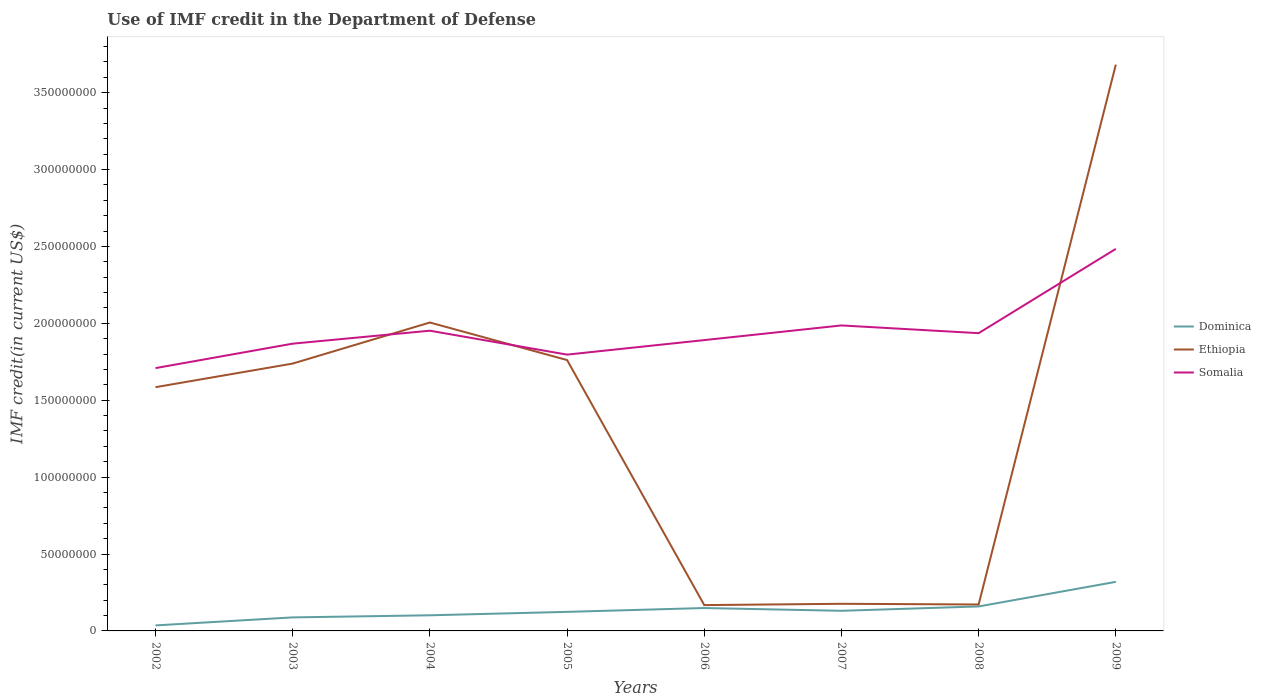Does the line corresponding to Somalia intersect with the line corresponding to Dominica?
Give a very brief answer. No. Across all years, what is the maximum IMF credit in the Department of Defense in Somalia?
Your answer should be very brief. 1.71e+08. In which year was the IMF credit in the Department of Defense in Dominica maximum?
Give a very brief answer. 2002. What is the total IMF credit in the Department of Defense in Somalia in the graph?
Ensure brevity in your answer.  -2.27e+07. What is the difference between the highest and the second highest IMF credit in the Department of Defense in Ethiopia?
Keep it short and to the point. 3.51e+08. Is the IMF credit in the Department of Defense in Ethiopia strictly greater than the IMF credit in the Department of Defense in Somalia over the years?
Offer a very short reply. No. How many legend labels are there?
Offer a terse response. 3. What is the title of the graph?
Offer a terse response. Use of IMF credit in the Department of Defense. What is the label or title of the X-axis?
Your response must be concise. Years. What is the label or title of the Y-axis?
Make the answer very short. IMF credit(in current US$). What is the IMF credit(in current US$) in Dominica in 2002?
Give a very brief answer. 3.59e+06. What is the IMF credit(in current US$) of Ethiopia in 2002?
Your answer should be very brief. 1.58e+08. What is the IMF credit(in current US$) of Somalia in 2002?
Provide a short and direct response. 1.71e+08. What is the IMF credit(in current US$) of Dominica in 2003?
Provide a short and direct response. 8.80e+06. What is the IMF credit(in current US$) in Ethiopia in 2003?
Your answer should be compact. 1.74e+08. What is the IMF credit(in current US$) of Somalia in 2003?
Provide a succinct answer. 1.87e+08. What is the IMF credit(in current US$) in Dominica in 2004?
Your answer should be very brief. 1.02e+07. What is the IMF credit(in current US$) of Ethiopia in 2004?
Offer a very short reply. 2.01e+08. What is the IMF credit(in current US$) in Somalia in 2004?
Offer a very short reply. 1.95e+08. What is the IMF credit(in current US$) of Dominica in 2005?
Ensure brevity in your answer.  1.24e+07. What is the IMF credit(in current US$) in Ethiopia in 2005?
Keep it short and to the point. 1.76e+08. What is the IMF credit(in current US$) of Somalia in 2005?
Keep it short and to the point. 1.80e+08. What is the IMF credit(in current US$) in Dominica in 2006?
Provide a succinct answer. 1.49e+07. What is the IMF credit(in current US$) of Ethiopia in 2006?
Provide a succinct answer. 1.68e+07. What is the IMF credit(in current US$) in Somalia in 2006?
Provide a succinct answer. 1.89e+08. What is the IMF credit(in current US$) of Dominica in 2007?
Your answer should be very brief. 1.31e+07. What is the IMF credit(in current US$) of Ethiopia in 2007?
Your response must be concise. 1.76e+07. What is the IMF credit(in current US$) in Somalia in 2007?
Offer a terse response. 1.99e+08. What is the IMF credit(in current US$) of Dominica in 2008?
Offer a terse response. 1.59e+07. What is the IMF credit(in current US$) of Ethiopia in 2008?
Provide a succinct answer. 1.72e+07. What is the IMF credit(in current US$) of Somalia in 2008?
Give a very brief answer. 1.94e+08. What is the IMF credit(in current US$) of Dominica in 2009?
Make the answer very short. 3.19e+07. What is the IMF credit(in current US$) of Ethiopia in 2009?
Offer a terse response. 3.68e+08. What is the IMF credit(in current US$) of Somalia in 2009?
Your answer should be very brief. 2.48e+08. Across all years, what is the maximum IMF credit(in current US$) in Dominica?
Offer a very short reply. 3.19e+07. Across all years, what is the maximum IMF credit(in current US$) in Ethiopia?
Make the answer very short. 3.68e+08. Across all years, what is the maximum IMF credit(in current US$) of Somalia?
Offer a terse response. 2.48e+08. Across all years, what is the minimum IMF credit(in current US$) in Dominica?
Give a very brief answer. 3.59e+06. Across all years, what is the minimum IMF credit(in current US$) of Ethiopia?
Give a very brief answer. 1.68e+07. Across all years, what is the minimum IMF credit(in current US$) in Somalia?
Offer a terse response. 1.71e+08. What is the total IMF credit(in current US$) of Dominica in the graph?
Your answer should be very brief. 1.11e+08. What is the total IMF credit(in current US$) of Ethiopia in the graph?
Provide a short and direct response. 1.13e+09. What is the total IMF credit(in current US$) in Somalia in the graph?
Give a very brief answer. 1.56e+09. What is the difference between the IMF credit(in current US$) in Dominica in 2002 and that in 2003?
Offer a very short reply. -5.21e+06. What is the difference between the IMF credit(in current US$) in Ethiopia in 2002 and that in 2003?
Your answer should be compact. -1.54e+07. What is the difference between the IMF credit(in current US$) of Somalia in 2002 and that in 2003?
Ensure brevity in your answer.  -1.59e+07. What is the difference between the IMF credit(in current US$) of Dominica in 2002 and that in 2004?
Your answer should be compact. -6.56e+06. What is the difference between the IMF credit(in current US$) of Ethiopia in 2002 and that in 2004?
Provide a succinct answer. -4.21e+07. What is the difference between the IMF credit(in current US$) of Somalia in 2002 and that in 2004?
Provide a short and direct response. -2.43e+07. What is the difference between the IMF credit(in current US$) in Dominica in 2002 and that in 2005?
Your response must be concise. -8.81e+06. What is the difference between the IMF credit(in current US$) in Ethiopia in 2002 and that in 2005?
Keep it short and to the point. -1.76e+07. What is the difference between the IMF credit(in current US$) in Somalia in 2002 and that in 2005?
Your response must be concise. -8.77e+06. What is the difference between the IMF credit(in current US$) of Dominica in 2002 and that in 2006?
Offer a very short reply. -1.13e+07. What is the difference between the IMF credit(in current US$) in Ethiopia in 2002 and that in 2006?
Provide a short and direct response. 1.42e+08. What is the difference between the IMF credit(in current US$) in Somalia in 2002 and that in 2006?
Make the answer very short. -1.82e+07. What is the difference between the IMF credit(in current US$) in Dominica in 2002 and that in 2007?
Make the answer very short. -9.49e+06. What is the difference between the IMF credit(in current US$) in Ethiopia in 2002 and that in 2007?
Offer a very short reply. 1.41e+08. What is the difference between the IMF credit(in current US$) in Somalia in 2002 and that in 2007?
Make the answer very short. -2.77e+07. What is the difference between the IMF credit(in current US$) of Dominica in 2002 and that in 2008?
Your answer should be very brief. -1.23e+07. What is the difference between the IMF credit(in current US$) in Ethiopia in 2002 and that in 2008?
Keep it short and to the point. 1.41e+08. What is the difference between the IMF credit(in current US$) in Somalia in 2002 and that in 2008?
Offer a terse response. -2.27e+07. What is the difference between the IMF credit(in current US$) in Dominica in 2002 and that in 2009?
Provide a short and direct response. -2.83e+07. What is the difference between the IMF credit(in current US$) in Ethiopia in 2002 and that in 2009?
Your answer should be compact. -2.10e+08. What is the difference between the IMF credit(in current US$) of Somalia in 2002 and that in 2009?
Provide a succinct answer. -7.75e+07. What is the difference between the IMF credit(in current US$) of Dominica in 2003 and that in 2004?
Give a very brief answer. -1.35e+06. What is the difference between the IMF credit(in current US$) in Ethiopia in 2003 and that in 2004?
Give a very brief answer. -2.67e+07. What is the difference between the IMF credit(in current US$) of Somalia in 2003 and that in 2004?
Make the answer very short. -8.43e+06. What is the difference between the IMF credit(in current US$) of Dominica in 2003 and that in 2005?
Make the answer very short. -3.60e+06. What is the difference between the IMF credit(in current US$) of Ethiopia in 2003 and that in 2005?
Offer a terse response. -2.28e+06. What is the difference between the IMF credit(in current US$) of Somalia in 2003 and that in 2005?
Provide a succinct answer. 7.13e+06. What is the difference between the IMF credit(in current US$) of Dominica in 2003 and that in 2006?
Keep it short and to the point. -6.08e+06. What is the difference between the IMF credit(in current US$) in Ethiopia in 2003 and that in 2006?
Provide a short and direct response. 1.57e+08. What is the difference between the IMF credit(in current US$) in Somalia in 2003 and that in 2006?
Provide a succinct answer. -2.32e+06. What is the difference between the IMF credit(in current US$) of Dominica in 2003 and that in 2007?
Your answer should be very brief. -4.28e+06. What is the difference between the IMF credit(in current US$) in Ethiopia in 2003 and that in 2007?
Your answer should be very brief. 1.56e+08. What is the difference between the IMF credit(in current US$) in Somalia in 2003 and that in 2007?
Your response must be concise. -1.19e+07. What is the difference between the IMF credit(in current US$) in Dominica in 2003 and that in 2008?
Provide a succinct answer. -7.11e+06. What is the difference between the IMF credit(in current US$) of Ethiopia in 2003 and that in 2008?
Provide a succinct answer. 1.57e+08. What is the difference between the IMF credit(in current US$) of Somalia in 2003 and that in 2008?
Offer a very short reply. -6.83e+06. What is the difference between the IMF credit(in current US$) of Dominica in 2003 and that in 2009?
Ensure brevity in your answer.  -2.31e+07. What is the difference between the IMF credit(in current US$) in Ethiopia in 2003 and that in 2009?
Your response must be concise. -1.94e+08. What is the difference between the IMF credit(in current US$) of Somalia in 2003 and that in 2009?
Provide a short and direct response. -6.16e+07. What is the difference between the IMF credit(in current US$) in Dominica in 2004 and that in 2005?
Keep it short and to the point. -2.24e+06. What is the difference between the IMF credit(in current US$) of Ethiopia in 2004 and that in 2005?
Ensure brevity in your answer.  2.44e+07. What is the difference between the IMF credit(in current US$) in Somalia in 2004 and that in 2005?
Your answer should be compact. 1.56e+07. What is the difference between the IMF credit(in current US$) of Dominica in 2004 and that in 2006?
Your answer should be very brief. -4.73e+06. What is the difference between the IMF credit(in current US$) in Ethiopia in 2004 and that in 2006?
Keep it short and to the point. 1.84e+08. What is the difference between the IMF credit(in current US$) in Somalia in 2004 and that in 2006?
Your answer should be compact. 6.11e+06. What is the difference between the IMF credit(in current US$) in Dominica in 2004 and that in 2007?
Ensure brevity in your answer.  -2.93e+06. What is the difference between the IMF credit(in current US$) of Ethiopia in 2004 and that in 2007?
Provide a short and direct response. 1.83e+08. What is the difference between the IMF credit(in current US$) in Somalia in 2004 and that in 2007?
Provide a short and direct response. -3.42e+06. What is the difference between the IMF credit(in current US$) in Dominica in 2004 and that in 2008?
Give a very brief answer. -5.76e+06. What is the difference between the IMF credit(in current US$) in Ethiopia in 2004 and that in 2008?
Give a very brief answer. 1.83e+08. What is the difference between the IMF credit(in current US$) of Somalia in 2004 and that in 2008?
Offer a terse response. 1.60e+06. What is the difference between the IMF credit(in current US$) of Dominica in 2004 and that in 2009?
Offer a terse response. -2.18e+07. What is the difference between the IMF credit(in current US$) in Ethiopia in 2004 and that in 2009?
Your answer should be very brief. -1.68e+08. What is the difference between the IMF credit(in current US$) in Somalia in 2004 and that in 2009?
Your answer should be very brief. -5.32e+07. What is the difference between the IMF credit(in current US$) in Dominica in 2005 and that in 2006?
Your answer should be compact. -2.49e+06. What is the difference between the IMF credit(in current US$) in Ethiopia in 2005 and that in 2006?
Your answer should be compact. 1.59e+08. What is the difference between the IMF credit(in current US$) in Somalia in 2005 and that in 2006?
Make the answer very short. -9.44e+06. What is the difference between the IMF credit(in current US$) in Dominica in 2005 and that in 2007?
Your answer should be very brief. -6.87e+05. What is the difference between the IMF credit(in current US$) in Ethiopia in 2005 and that in 2007?
Your answer should be compact. 1.58e+08. What is the difference between the IMF credit(in current US$) in Somalia in 2005 and that in 2007?
Provide a succinct answer. -1.90e+07. What is the difference between the IMF credit(in current US$) of Dominica in 2005 and that in 2008?
Provide a short and direct response. -3.51e+06. What is the difference between the IMF credit(in current US$) of Ethiopia in 2005 and that in 2008?
Offer a very short reply. 1.59e+08. What is the difference between the IMF credit(in current US$) in Somalia in 2005 and that in 2008?
Ensure brevity in your answer.  -1.40e+07. What is the difference between the IMF credit(in current US$) of Dominica in 2005 and that in 2009?
Keep it short and to the point. -1.95e+07. What is the difference between the IMF credit(in current US$) of Ethiopia in 2005 and that in 2009?
Your answer should be compact. -1.92e+08. What is the difference between the IMF credit(in current US$) of Somalia in 2005 and that in 2009?
Give a very brief answer. -6.88e+07. What is the difference between the IMF credit(in current US$) in Dominica in 2006 and that in 2007?
Provide a succinct answer. 1.80e+06. What is the difference between the IMF credit(in current US$) of Ethiopia in 2006 and that in 2007?
Offer a very short reply. -8.47e+05. What is the difference between the IMF credit(in current US$) of Somalia in 2006 and that in 2007?
Your answer should be very brief. -9.53e+06. What is the difference between the IMF credit(in current US$) of Dominica in 2006 and that in 2008?
Offer a very short reply. -1.03e+06. What is the difference between the IMF credit(in current US$) of Ethiopia in 2006 and that in 2008?
Your answer should be very brief. -4.00e+05. What is the difference between the IMF credit(in current US$) of Somalia in 2006 and that in 2008?
Give a very brief answer. -4.51e+06. What is the difference between the IMF credit(in current US$) of Dominica in 2006 and that in 2009?
Your answer should be compact. -1.70e+07. What is the difference between the IMF credit(in current US$) of Ethiopia in 2006 and that in 2009?
Provide a succinct answer. -3.51e+08. What is the difference between the IMF credit(in current US$) in Somalia in 2006 and that in 2009?
Offer a terse response. -5.93e+07. What is the difference between the IMF credit(in current US$) in Dominica in 2007 and that in 2008?
Your answer should be very brief. -2.83e+06. What is the difference between the IMF credit(in current US$) of Ethiopia in 2007 and that in 2008?
Ensure brevity in your answer.  4.47e+05. What is the difference between the IMF credit(in current US$) in Somalia in 2007 and that in 2008?
Your answer should be compact. 5.02e+06. What is the difference between the IMF credit(in current US$) in Dominica in 2007 and that in 2009?
Ensure brevity in your answer.  -1.88e+07. What is the difference between the IMF credit(in current US$) of Ethiopia in 2007 and that in 2009?
Your answer should be very brief. -3.51e+08. What is the difference between the IMF credit(in current US$) in Somalia in 2007 and that in 2009?
Make the answer very short. -4.98e+07. What is the difference between the IMF credit(in current US$) in Dominica in 2008 and that in 2009?
Offer a very short reply. -1.60e+07. What is the difference between the IMF credit(in current US$) of Ethiopia in 2008 and that in 2009?
Make the answer very short. -3.51e+08. What is the difference between the IMF credit(in current US$) in Somalia in 2008 and that in 2009?
Offer a terse response. -5.48e+07. What is the difference between the IMF credit(in current US$) of Dominica in 2002 and the IMF credit(in current US$) of Ethiopia in 2003?
Give a very brief answer. -1.70e+08. What is the difference between the IMF credit(in current US$) of Dominica in 2002 and the IMF credit(in current US$) of Somalia in 2003?
Your answer should be very brief. -1.83e+08. What is the difference between the IMF credit(in current US$) in Ethiopia in 2002 and the IMF credit(in current US$) in Somalia in 2003?
Ensure brevity in your answer.  -2.83e+07. What is the difference between the IMF credit(in current US$) in Dominica in 2002 and the IMF credit(in current US$) in Ethiopia in 2004?
Your answer should be very brief. -1.97e+08. What is the difference between the IMF credit(in current US$) in Dominica in 2002 and the IMF credit(in current US$) in Somalia in 2004?
Offer a very short reply. -1.92e+08. What is the difference between the IMF credit(in current US$) in Ethiopia in 2002 and the IMF credit(in current US$) in Somalia in 2004?
Your response must be concise. -3.67e+07. What is the difference between the IMF credit(in current US$) of Dominica in 2002 and the IMF credit(in current US$) of Ethiopia in 2005?
Keep it short and to the point. -1.73e+08. What is the difference between the IMF credit(in current US$) of Dominica in 2002 and the IMF credit(in current US$) of Somalia in 2005?
Ensure brevity in your answer.  -1.76e+08. What is the difference between the IMF credit(in current US$) of Ethiopia in 2002 and the IMF credit(in current US$) of Somalia in 2005?
Your response must be concise. -2.12e+07. What is the difference between the IMF credit(in current US$) in Dominica in 2002 and the IMF credit(in current US$) in Ethiopia in 2006?
Make the answer very short. -1.32e+07. What is the difference between the IMF credit(in current US$) in Dominica in 2002 and the IMF credit(in current US$) in Somalia in 2006?
Ensure brevity in your answer.  -1.86e+08. What is the difference between the IMF credit(in current US$) of Ethiopia in 2002 and the IMF credit(in current US$) of Somalia in 2006?
Provide a short and direct response. -3.06e+07. What is the difference between the IMF credit(in current US$) in Dominica in 2002 and the IMF credit(in current US$) in Ethiopia in 2007?
Your response must be concise. -1.40e+07. What is the difference between the IMF credit(in current US$) of Dominica in 2002 and the IMF credit(in current US$) of Somalia in 2007?
Your answer should be very brief. -1.95e+08. What is the difference between the IMF credit(in current US$) of Ethiopia in 2002 and the IMF credit(in current US$) of Somalia in 2007?
Make the answer very short. -4.02e+07. What is the difference between the IMF credit(in current US$) in Dominica in 2002 and the IMF credit(in current US$) in Ethiopia in 2008?
Your response must be concise. -1.36e+07. What is the difference between the IMF credit(in current US$) in Dominica in 2002 and the IMF credit(in current US$) in Somalia in 2008?
Ensure brevity in your answer.  -1.90e+08. What is the difference between the IMF credit(in current US$) of Ethiopia in 2002 and the IMF credit(in current US$) of Somalia in 2008?
Your answer should be very brief. -3.51e+07. What is the difference between the IMF credit(in current US$) in Dominica in 2002 and the IMF credit(in current US$) in Ethiopia in 2009?
Your response must be concise. -3.65e+08. What is the difference between the IMF credit(in current US$) of Dominica in 2002 and the IMF credit(in current US$) of Somalia in 2009?
Keep it short and to the point. -2.45e+08. What is the difference between the IMF credit(in current US$) of Ethiopia in 2002 and the IMF credit(in current US$) of Somalia in 2009?
Offer a terse response. -8.99e+07. What is the difference between the IMF credit(in current US$) of Dominica in 2003 and the IMF credit(in current US$) of Ethiopia in 2004?
Ensure brevity in your answer.  -1.92e+08. What is the difference between the IMF credit(in current US$) of Dominica in 2003 and the IMF credit(in current US$) of Somalia in 2004?
Offer a very short reply. -1.86e+08. What is the difference between the IMF credit(in current US$) in Ethiopia in 2003 and the IMF credit(in current US$) in Somalia in 2004?
Ensure brevity in your answer.  -2.14e+07. What is the difference between the IMF credit(in current US$) of Dominica in 2003 and the IMF credit(in current US$) of Ethiopia in 2005?
Your answer should be compact. -1.67e+08. What is the difference between the IMF credit(in current US$) in Dominica in 2003 and the IMF credit(in current US$) in Somalia in 2005?
Provide a short and direct response. -1.71e+08. What is the difference between the IMF credit(in current US$) of Ethiopia in 2003 and the IMF credit(in current US$) of Somalia in 2005?
Your answer should be very brief. -5.81e+06. What is the difference between the IMF credit(in current US$) of Dominica in 2003 and the IMF credit(in current US$) of Ethiopia in 2006?
Your answer should be compact. -7.99e+06. What is the difference between the IMF credit(in current US$) of Dominica in 2003 and the IMF credit(in current US$) of Somalia in 2006?
Ensure brevity in your answer.  -1.80e+08. What is the difference between the IMF credit(in current US$) in Ethiopia in 2003 and the IMF credit(in current US$) in Somalia in 2006?
Give a very brief answer. -1.53e+07. What is the difference between the IMF credit(in current US$) in Dominica in 2003 and the IMF credit(in current US$) in Ethiopia in 2007?
Offer a terse response. -8.84e+06. What is the difference between the IMF credit(in current US$) in Dominica in 2003 and the IMF credit(in current US$) in Somalia in 2007?
Make the answer very short. -1.90e+08. What is the difference between the IMF credit(in current US$) in Ethiopia in 2003 and the IMF credit(in current US$) in Somalia in 2007?
Your response must be concise. -2.48e+07. What is the difference between the IMF credit(in current US$) in Dominica in 2003 and the IMF credit(in current US$) in Ethiopia in 2008?
Offer a very short reply. -8.39e+06. What is the difference between the IMF credit(in current US$) of Dominica in 2003 and the IMF credit(in current US$) of Somalia in 2008?
Your answer should be compact. -1.85e+08. What is the difference between the IMF credit(in current US$) in Ethiopia in 2003 and the IMF credit(in current US$) in Somalia in 2008?
Give a very brief answer. -1.98e+07. What is the difference between the IMF credit(in current US$) in Dominica in 2003 and the IMF credit(in current US$) in Ethiopia in 2009?
Provide a succinct answer. -3.59e+08. What is the difference between the IMF credit(in current US$) in Dominica in 2003 and the IMF credit(in current US$) in Somalia in 2009?
Provide a succinct answer. -2.40e+08. What is the difference between the IMF credit(in current US$) of Ethiopia in 2003 and the IMF credit(in current US$) of Somalia in 2009?
Provide a short and direct response. -7.46e+07. What is the difference between the IMF credit(in current US$) of Dominica in 2004 and the IMF credit(in current US$) of Ethiopia in 2005?
Offer a very short reply. -1.66e+08. What is the difference between the IMF credit(in current US$) in Dominica in 2004 and the IMF credit(in current US$) in Somalia in 2005?
Keep it short and to the point. -1.70e+08. What is the difference between the IMF credit(in current US$) in Ethiopia in 2004 and the IMF credit(in current US$) in Somalia in 2005?
Give a very brief answer. 2.09e+07. What is the difference between the IMF credit(in current US$) in Dominica in 2004 and the IMF credit(in current US$) in Ethiopia in 2006?
Your answer should be very brief. -6.64e+06. What is the difference between the IMF credit(in current US$) of Dominica in 2004 and the IMF credit(in current US$) of Somalia in 2006?
Ensure brevity in your answer.  -1.79e+08. What is the difference between the IMF credit(in current US$) of Ethiopia in 2004 and the IMF credit(in current US$) of Somalia in 2006?
Offer a terse response. 1.14e+07. What is the difference between the IMF credit(in current US$) in Dominica in 2004 and the IMF credit(in current US$) in Ethiopia in 2007?
Offer a terse response. -7.48e+06. What is the difference between the IMF credit(in current US$) in Dominica in 2004 and the IMF credit(in current US$) in Somalia in 2007?
Ensure brevity in your answer.  -1.88e+08. What is the difference between the IMF credit(in current US$) in Ethiopia in 2004 and the IMF credit(in current US$) in Somalia in 2007?
Give a very brief answer. 1.90e+06. What is the difference between the IMF credit(in current US$) in Dominica in 2004 and the IMF credit(in current US$) in Ethiopia in 2008?
Make the answer very short. -7.04e+06. What is the difference between the IMF credit(in current US$) in Dominica in 2004 and the IMF credit(in current US$) in Somalia in 2008?
Your answer should be very brief. -1.83e+08. What is the difference between the IMF credit(in current US$) of Ethiopia in 2004 and the IMF credit(in current US$) of Somalia in 2008?
Ensure brevity in your answer.  6.93e+06. What is the difference between the IMF credit(in current US$) of Dominica in 2004 and the IMF credit(in current US$) of Ethiopia in 2009?
Offer a very short reply. -3.58e+08. What is the difference between the IMF credit(in current US$) in Dominica in 2004 and the IMF credit(in current US$) in Somalia in 2009?
Offer a terse response. -2.38e+08. What is the difference between the IMF credit(in current US$) of Ethiopia in 2004 and the IMF credit(in current US$) of Somalia in 2009?
Ensure brevity in your answer.  -4.79e+07. What is the difference between the IMF credit(in current US$) in Dominica in 2005 and the IMF credit(in current US$) in Ethiopia in 2006?
Offer a very short reply. -4.39e+06. What is the difference between the IMF credit(in current US$) of Dominica in 2005 and the IMF credit(in current US$) of Somalia in 2006?
Ensure brevity in your answer.  -1.77e+08. What is the difference between the IMF credit(in current US$) of Ethiopia in 2005 and the IMF credit(in current US$) of Somalia in 2006?
Make the answer very short. -1.30e+07. What is the difference between the IMF credit(in current US$) in Dominica in 2005 and the IMF credit(in current US$) in Ethiopia in 2007?
Provide a succinct answer. -5.24e+06. What is the difference between the IMF credit(in current US$) of Dominica in 2005 and the IMF credit(in current US$) of Somalia in 2007?
Give a very brief answer. -1.86e+08. What is the difference between the IMF credit(in current US$) in Ethiopia in 2005 and the IMF credit(in current US$) in Somalia in 2007?
Your answer should be compact. -2.25e+07. What is the difference between the IMF credit(in current US$) of Dominica in 2005 and the IMF credit(in current US$) of Ethiopia in 2008?
Offer a terse response. -4.79e+06. What is the difference between the IMF credit(in current US$) of Dominica in 2005 and the IMF credit(in current US$) of Somalia in 2008?
Your answer should be compact. -1.81e+08. What is the difference between the IMF credit(in current US$) in Ethiopia in 2005 and the IMF credit(in current US$) in Somalia in 2008?
Ensure brevity in your answer.  -1.75e+07. What is the difference between the IMF credit(in current US$) of Dominica in 2005 and the IMF credit(in current US$) of Ethiopia in 2009?
Make the answer very short. -3.56e+08. What is the difference between the IMF credit(in current US$) of Dominica in 2005 and the IMF credit(in current US$) of Somalia in 2009?
Keep it short and to the point. -2.36e+08. What is the difference between the IMF credit(in current US$) of Ethiopia in 2005 and the IMF credit(in current US$) of Somalia in 2009?
Make the answer very short. -7.23e+07. What is the difference between the IMF credit(in current US$) of Dominica in 2006 and the IMF credit(in current US$) of Ethiopia in 2007?
Provide a succinct answer. -2.75e+06. What is the difference between the IMF credit(in current US$) in Dominica in 2006 and the IMF credit(in current US$) in Somalia in 2007?
Offer a very short reply. -1.84e+08. What is the difference between the IMF credit(in current US$) in Ethiopia in 2006 and the IMF credit(in current US$) in Somalia in 2007?
Offer a terse response. -1.82e+08. What is the difference between the IMF credit(in current US$) in Dominica in 2006 and the IMF credit(in current US$) in Ethiopia in 2008?
Your response must be concise. -2.31e+06. What is the difference between the IMF credit(in current US$) in Dominica in 2006 and the IMF credit(in current US$) in Somalia in 2008?
Offer a terse response. -1.79e+08. What is the difference between the IMF credit(in current US$) in Ethiopia in 2006 and the IMF credit(in current US$) in Somalia in 2008?
Provide a succinct answer. -1.77e+08. What is the difference between the IMF credit(in current US$) in Dominica in 2006 and the IMF credit(in current US$) in Ethiopia in 2009?
Offer a terse response. -3.53e+08. What is the difference between the IMF credit(in current US$) of Dominica in 2006 and the IMF credit(in current US$) of Somalia in 2009?
Ensure brevity in your answer.  -2.34e+08. What is the difference between the IMF credit(in current US$) in Ethiopia in 2006 and the IMF credit(in current US$) in Somalia in 2009?
Provide a succinct answer. -2.32e+08. What is the difference between the IMF credit(in current US$) of Dominica in 2007 and the IMF credit(in current US$) of Ethiopia in 2008?
Provide a succinct answer. -4.11e+06. What is the difference between the IMF credit(in current US$) of Dominica in 2007 and the IMF credit(in current US$) of Somalia in 2008?
Provide a short and direct response. -1.81e+08. What is the difference between the IMF credit(in current US$) in Ethiopia in 2007 and the IMF credit(in current US$) in Somalia in 2008?
Offer a very short reply. -1.76e+08. What is the difference between the IMF credit(in current US$) in Dominica in 2007 and the IMF credit(in current US$) in Ethiopia in 2009?
Offer a very short reply. -3.55e+08. What is the difference between the IMF credit(in current US$) of Dominica in 2007 and the IMF credit(in current US$) of Somalia in 2009?
Your answer should be compact. -2.35e+08. What is the difference between the IMF credit(in current US$) in Ethiopia in 2007 and the IMF credit(in current US$) in Somalia in 2009?
Ensure brevity in your answer.  -2.31e+08. What is the difference between the IMF credit(in current US$) in Dominica in 2008 and the IMF credit(in current US$) in Ethiopia in 2009?
Make the answer very short. -3.52e+08. What is the difference between the IMF credit(in current US$) of Dominica in 2008 and the IMF credit(in current US$) of Somalia in 2009?
Ensure brevity in your answer.  -2.33e+08. What is the difference between the IMF credit(in current US$) in Ethiopia in 2008 and the IMF credit(in current US$) in Somalia in 2009?
Offer a very short reply. -2.31e+08. What is the average IMF credit(in current US$) in Dominica per year?
Provide a succinct answer. 1.38e+07. What is the average IMF credit(in current US$) of Ethiopia per year?
Provide a short and direct response. 1.41e+08. What is the average IMF credit(in current US$) of Somalia per year?
Your response must be concise. 1.95e+08. In the year 2002, what is the difference between the IMF credit(in current US$) of Dominica and IMF credit(in current US$) of Ethiopia?
Ensure brevity in your answer.  -1.55e+08. In the year 2002, what is the difference between the IMF credit(in current US$) in Dominica and IMF credit(in current US$) in Somalia?
Make the answer very short. -1.67e+08. In the year 2002, what is the difference between the IMF credit(in current US$) of Ethiopia and IMF credit(in current US$) of Somalia?
Provide a succinct answer. -1.24e+07. In the year 2003, what is the difference between the IMF credit(in current US$) of Dominica and IMF credit(in current US$) of Ethiopia?
Offer a very short reply. -1.65e+08. In the year 2003, what is the difference between the IMF credit(in current US$) in Dominica and IMF credit(in current US$) in Somalia?
Give a very brief answer. -1.78e+08. In the year 2003, what is the difference between the IMF credit(in current US$) in Ethiopia and IMF credit(in current US$) in Somalia?
Your answer should be very brief. -1.29e+07. In the year 2004, what is the difference between the IMF credit(in current US$) in Dominica and IMF credit(in current US$) in Ethiopia?
Keep it short and to the point. -1.90e+08. In the year 2004, what is the difference between the IMF credit(in current US$) in Dominica and IMF credit(in current US$) in Somalia?
Make the answer very short. -1.85e+08. In the year 2004, what is the difference between the IMF credit(in current US$) in Ethiopia and IMF credit(in current US$) in Somalia?
Your response must be concise. 5.33e+06. In the year 2005, what is the difference between the IMF credit(in current US$) of Dominica and IMF credit(in current US$) of Ethiopia?
Provide a succinct answer. -1.64e+08. In the year 2005, what is the difference between the IMF credit(in current US$) of Dominica and IMF credit(in current US$) of Somalia?
Make the answer very short. -1.67e+08. In the year 2005, what is the difference between the IMF credit(in current US$) of Ethiopia and IMF credit(in current US$) of Somalia?
Keep it short and to the point. -3.53e+06. In the year 2006, what is the difference between the IMF credit(in current US$) of Dominica and IMF credit(in current US$) of Ethiopia?
Keep it short and to the point. -1.91e+06. In the year 2006, what is the difference between the IMF credit(in current US$) of Dominica and IMF credit(in current US$) of Somalia?
Offer a very short reply. -1.74e+08. In the year 2006, what is the difference between the IMF credit(in current US$) of Ethiopia and IMF credit(in current US$) of Somalia?
Offer a very short reply. -1.72e+08. In the year 2007, what is the difference between the IMF credit(in current US$) in Dominica and IMF credit(in current US$) in Ethiopia?
Make the answer very short. -4.55e+06. In the year 2007, what is the difference between the IMF credit(in current US$) of Dominica and IMF credit(in current US$) of Somalia?
Keep it short and to the point. -1.86e+08. In the year 2007, what is the difference between the IMF credit(in current US$) in Ethiopia and IMF credit(in current US$) in Somalia?
Offer a terse response. -1.81e+08. In the year 2008, what is the difference between the IMF credit(in current US$) in Dominica and IMF credit(in current US$) in Ethiopia?
Your answer should be very brief. -1.28e+06. In the year 2008, what is the difference between the IMF credit(in current US$) in Dominica and IMF credit(in current US$) in Somalia?
Your answer should be very brief. -1.78e+08. In the year 2008, what is the difference between the IMF credit(in current US$) of Ethiopia and IMF credit(in current US$) of Somalia?
Make the answer very short. -1.76e+08. In the year 2009, what is the difference between the IMF credit(in current US$) in Dominica and IMF credit(in current US$) in Ethiopia?
Your answer should be very brief. -3.36e+08. In the year 2009, what is the difference between the IMF credit(in current US$) in Dominica and IMF credit(in current US$) in Somalia?
Provide a short and direct response. -2.17e+08. In the year 2009, what is the difference between the IMF credit(in current US$) in Ethiopia and IMF credit(in current US$) in Somalia?
Ensure brevity in your answer.  1.20e+08. What is the ratio of the IMF credit(in current US$) in Dominica in 2002 to that in 2003?
Keep it short and to the point. 0.41. What is the ratio of the IMF credit(in current US$) of Ethiopia in 2002 to that in 2003?
Your answer should be compact. 0.91. What is the ratio of the IMF credit(in current US$) of Somalia in 2002 to that in 2003?
Keep it short and to the point. 0.91. What is the ratio of the IMF credit(in current US$) in Dominica in 2002 to that in 2004?
Offer a very short reply. 0.35. What is the ratio of the IMF credit(in current US$) in Ethiopia in 2002 to that in 2004?
Offer a very short reply. 0.79. What is the ratio of the IMF credit(in current US$) of Somalia in 2002 to that in 2004?
Your answer should be compact. 0.88. What is the ratio of the IMF credit(in current US$) of Dominica in 2002 to that in 2005?
Your response must be concise. 0.29. What is the ratio of the IMF credit(in current US$) in Ethiopia in 2002 to that in 2005?
Provide a succinct answer. 0.9. What is the ratio of the IMF credit(in current US$) in Somalia in 2002 to that in 2005?
Offer a terse response. 0.95. What is the ratio of the IMF credit(in current US$) of Dominica in 2002 to that in 2006?
Your answer should be very brief. 0.24. What is the ratio of the IMF credit(in current US$) in Ethiopia in 2002 to that in 2006?
Give a very brief answer. 9.44. What is the ratio of the IMF credit(in current US$) of Somalia in 2002 to that in 2006?
Provide a short and direct response. 0.9. What is the ratio of the IMF credit(in current US$) in Dominica in 2002 to that in 2007?
Give a very brief answer. 0.27. What is the ratio of the IMF credit(in current US$) in Ethiopia in 2002 to that in 2007?
Your response must be concise. 8.99. What is the ratio of the IMF credit(in current US$) of Somalia in 2002 to that in 2007?
Provide a short and direct response. 0.86. What is the ratio of the IMF credit(in current US$) of Dominica in 2002 to that in 2008?
Provide a short and direct response. 0.23. What is the ratio of the IMF credit(in current US$) of Ethiopia in 2002 to that in 2008?
Provide a succinct answer. 9.22. What is the ratio of the IMF credit(in current US$) of Somalia in 2002 to that in 2008?
Give a very brief answer. 0.88. What is the ratio of the IMF credit(in current US$) of Dominica in 2002 to that in 2009?
Ensure brevity in your answer.  0.11. What is the ratio of the IMF credit(in current US$) in Ethiopia in 2002 to that in 2009?
Make the answer very short. 0.43. What is the ratio of the IMF credit(in current US$) in Somalia in 2002 to that in 2009?
Your answer should be compact. 0.69. What is the ratio of the IMF credit(in current US$) in Dominica in 2003 to that in 2004?
Give a very brief answer. 0.87. What is the ratio of the IMF credit(in current US$) in Ethiopia in 2003 to that in 2004?
Your answer should be very brief. 0.87. What is the ratio of the IMF credit(in current US$) of Somalia in 2003 to that in 2004?
Make the answer very short. 0.96. What is the ratio of the IMF credit(in current US$) in Dominica in 2003 to that in 2005?
Provide a short and direct response. 0.71. What is the ratio of the IMF credit(in current US$) in Ethiopia in 2003 to that in 2005?
Offer a very short reply. 0.99. What is the ratio of the IMF credit(in current US$) of Somalia in 2003 to that in 2005?
Keep it short and to the point. 1.04. What is the ratio of the IMF credit(in current US$) in Dominica in 2003 to that in 2006?
Offer a terse response. 0.59. What is the ratio of the IMF credit(in current US$) of Ethiopia in 2003 to that in 2006?
Provide a succinct answer. 10.35. What is the ratio of the IMF credit(in current US$) in Somalia in 2003 to that in 2006?
Your answer should be very brief. 0.99. What is the ratio of the IMF credit(in current US$) in Dominica in 2003 to that in 2007?
Provide a succinct answer. 0.67. What is the ratio of the IMF credit(in current US$) in Ethiopia in 2003 to that in 2007?
Offer a terse response. 9.86. What is the ratio of the IMF credit(in current US$) in Somalia in 2003 to that in 2007?
Your answer should be compact. 0.94. What is the ratio of the IMF credit(in current US$) in Dominica in 2003 to that in 2008?
Keep it short and to the point. 0.55. What is the ratio of the IMF credit(in current US$) of Ethiopia in 2003 to that in 2008?
Your response must be concise. 10.11. What is the ratio of the IMF credit(in current US$) in Somalia in 2003 to that in 2008?
Make the answer very short. 0.96. What is the ratio of the IMF credit(in current US$) of Dominica in 2003 to that in 2009?
Offer a terse response. 0.28. What is the ratio of the IMF credit(in current US$) in Ethiopia in 2003 to that in 2009?
Offer a terse response. 0.47. What is the ratio of the IMF credit(in current US$) in Somalia in 2003 to that in 2009?
Your answer should be very brief. 0.75. What is the ratio of the IMF credit(in current US$) in Dominica in 2004 to that in 2005?
Give a very brief answer. 0.82. What is the ratio of the IMF credit(in current US$) in Ethiopia in 2004 to that in 2005?
Your answer should be very brief. 1.14. What is the ratio of the IMF credit(in current US$) of Somalia in 2004 to that in 2005?
Ensure brevity in your answer.  1.09. What is the ratio of the IMF credit(in current US$) in Dominica in 2004 to that in 2006?
Offer a terse response. 0.68. What is the ratio of the IMF credit(in current US$) of Ethiopia in 2004 to that in 2006?
Keep it short and to the point. 11.94. What is the ratio of the IMF credit(in current US$) of Somalia in 2004 to that in 2006?
Give a very brief answer. 1.03. What is the ratio of the IMF credit(in current US$) of Dominica in 2004 to that in 2007?
Make the answer very short. 0.78. What is the ratio of the IMF credit(in current US$) of Ethiopia in 2004 to that in 2007?
Ensure brevity in your answer.  11.37. What is the ratio of the IMF credit(in current US$) of Somalia in 2004 to that in 2007?
Your response must be concise. 0.98. What is the ratio of the IMF credit(in current US$) in Dominica in 2004 to that in 2008?
Keep it short and to the point. 0.64. What is the ratio of the IMF credit(in current US$) of Ethiopia in 2004 to that in 2008?
Keep it short and to the point. 11.67. What is the ratio of the IMF credit(in current US$) in Somalia in 2004 to that in 2008?
Offer a terse response. 1.01. What is the ratio of the IMF credit(in current US$) in Dominica in 2004 to that in 2009?
Make the answer very short. 0.32. What is the ratio of the IMF credit(in current US$) in Ethiopia in 2004 to that in 2009?
Make the answer very short. 0.54. What is the ratio of the IMF credit(in current US$) of Somalia in 2004 to that in 2009?
Ensure brevity in your answer.  0.79. What is the ratio of the IMF credit(in current US$) of Dominica in 2005 to that in 2006?
Offer a terse response. 0.83. What is the ratio of the IMF credit(in current US$) of Ethiopia in 2005 to that in 2006?
Provide a succinct answer. 10.49. What is the ratio of the IMF credit(in current US$) of Somalia in 2005 to that in 2006?
Your answer should be very brief. 0.95. What is the ratio of the IMF credit(in current US$) in Dominica in 2005 to that in 2007?
Make the answer very short. 0.95. What is the ratio of the IMF credit(in current US$) of Ethiopia in 2005 to that in 2007?
Give a very brief answer. 9.99. What is the ratio of the IMF credit(in current US$) in Somalia in 2005 to that in 2007?
Offer a terse response. 0.9. What is the ratio of the IMF credit(in current US$) of Dominica in 2005 to that in 2008?
Ensure brevity in your answer.  0.78. What is the ratio of the IMF credit(in current US$) of Ethiopia in 2005 to that in 2008?
Your response must be concise. 10.25. What is the ratio of the IMF credit(in current US$) in Somalia in 2005 to that in 2008?
Provide a succinct answer. 0.93. What is the ratio of the IMF credit(in current US$) in Dominica in 2005 to that in 2009?
Keep it short and to the point. 0.39. What is the ratio of the IMF credit(in current US$) in Ethiopia in 2005 to that in 2009?
Ensure brevity in your answer.  0.48. What is the ratio of the IMF credit(in current US$) in Somalia in 2005 to that in 2009?
Your response must be concise. 0.72. What is the ratio of the IMF credit(in current US$) of Dominica in 2006 to that in 2007?
Provide a short and direct response. 1.14. What is the ratio of the IMF credit(in current US$) in Ethiopia in 2006 to that in 2007?
Offer a terse response. 0.95. What is the ratio of the IMF credit(in current US$) in Dominica in 2006 to that in 2008?
Give a very brief answer. 0.94. What is the ratio of the IMF credit(in current US$) in Ethiopia in 2006 to that in 2008?
Offer a terse response. 0.98. What is the ratio of the IMF credit(in current US$) in Somalia in 2006 to that in 2008?
Make the answer very short. 0.98. What is the ratio of the IMF credit(in current US$) of Dominica in 2006 to that in 2009?
Provide a succinct answer. 0.47. What is the ratio of the IMF credit(in current US$) of Ethiopia in 2006 to that in 2009?
Your response must be concise. 0.05. What is the ratio of the IMF credit(in current US$) in Somalia in 2006 to that in 2009?
Your response must be concise. 0.76. What is the ratio of the IMF credit(in current US$) in Dominica in 2007 to that in 2008?
Give a very brief answer. 0.82. What is the ratio of the IMF credit(in current US$) in Dominica in 2007 to that in 2009?
Provide a short and direct response. 0.41. What is the ratio of the IMF credit(in current US$) of Ethiopia in 2007 to that in 2009?
Ensure brevity in your answer.  0.05. What is the ratio of the IMF credit(in current US$) of Somalia in 2007 to that in 2009?
Your response must be concise. 0.8. What is the ratio of the IMF credit(in current US$) in Dominica in 2008 to that in 2009?
Provide a succinct answer. 0.5. What is the ratio of the IMF credit(in current US$) of Ethiopia in 2008 to that in 2009?
Provide a short and direct response. 0.05. What is the ratio of the IMF credit(in current US$) in Somalia in 2008 to that in 2009?
Your response must be concise. 0.78. What is the difference between the highest and the second highest IMF credit(in current US$) of Dominica?
Your answer should be very brief. 1.60e+07. What is the difference between the highest and the second highest IMF credit(in current US$) in Ethiopia?
Ensure brevity in your answer.  1.68e+08. What is the difference between the highest and the second highest IMF credit(in current US$) in Somalia?
Your answer should be compact. 4.98e+07. What is the difference between the highest and the lowest IMF credit(in current US$) in Dominica?
Offer a terse response. 2.83e+07. What is the difference between the highest and the lowest IMF credit(in current US$) in Ethiopia?
Keep it short and to the point. 3.51e+08. What is the difference between the highest and the lowest IMF credit(in current US$) of Somalia?
Keep it short and to the point. 7.75e+07. 